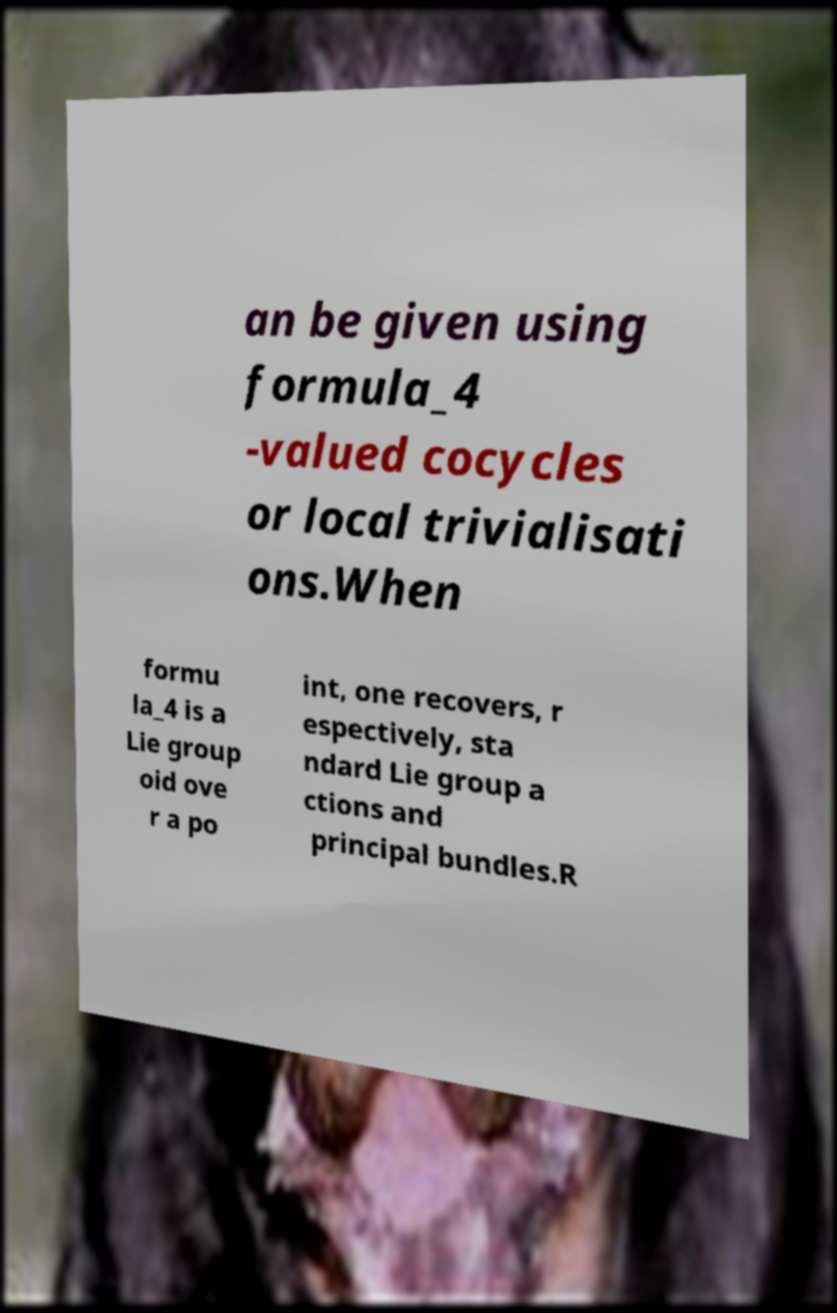Could you extract and type out the text from this image? an be given using formula_4 -valued cocycles or local trivialisati ons.When formu la_4 is a Lie group oid ove r a po int, one recovers, r espectively, sta ndard Lie group a ctions and principal bundles.R 